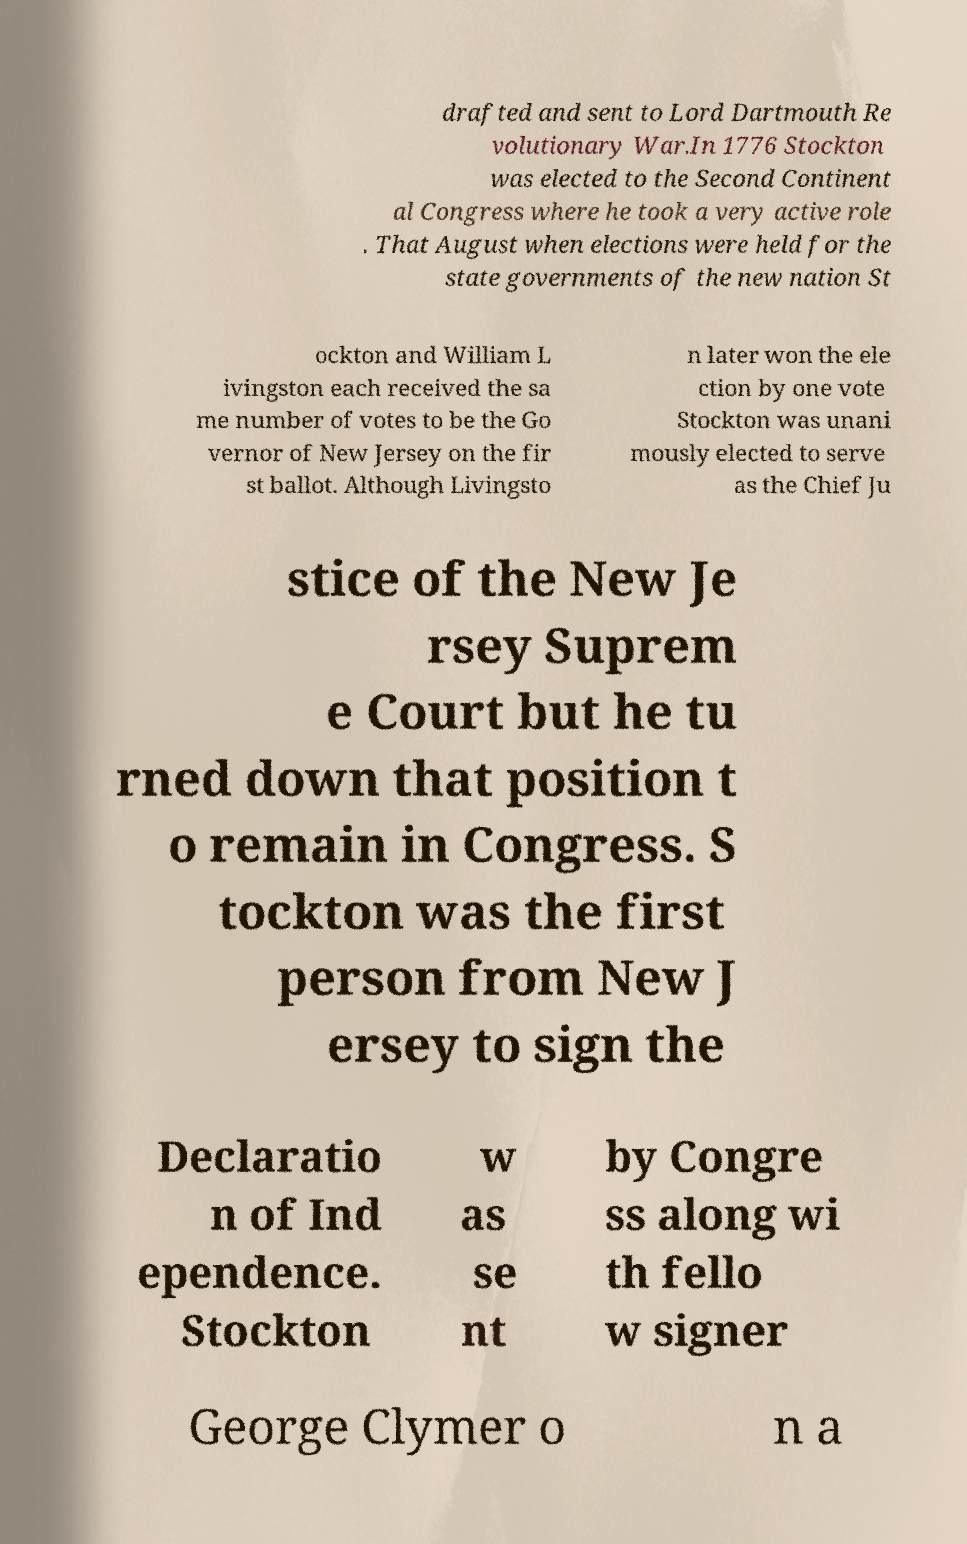Can you accurately transcribe the text from the provided image for me? drafted and sent to Lord Dartmouth Re volutionary War.In 1776 Stockton was elected to the Second Continent al Congress where he took a very active role . That August when elections were held for the state governments of the new nation St ockton and William L ivingston each received the sa me number of votes to be the Go vernor of New Jersey on the fir st ballot. Although Livingsto n later won the ele ction by one vote Stockton was unani mously elected to serve as the Chief Ju stice of the New Je rsey Suprem e Court but he tu rned down that position t o remain in Congress. S tockton was the first person from New J ersey to sign the Declaratio n of Ind ependence. Stockton w as se nt by Congre ss along wi th fello w signer George Clymer o n a 